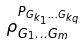Convert formula to latex. <formula><loc_0><loc_0><loc_500><loc_500>\rho _ { G _ { 1 } \dots G _ { m } } ^ { P _ { G _ { k _ { 1 } } \dots G _ { k _ { q } } } }</formula> 